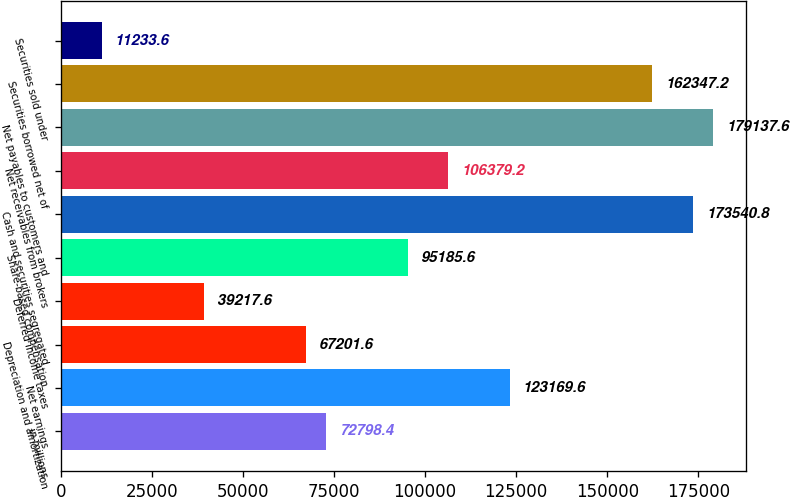Convert chart to OTSL. <chart><loc_0><loc_0><loc_500><loc_500><bar_chart><fcel>in millions<fcel>Net earnings<fcel>Depreciation and amortization<fcel>Deferred income taxes<fcel>Share-based compensation<fcel>Cash and securities segregated<fcel>Net receivables from brokers<fcel>Net payables to customers and<fcel>Securities borrowed net of<fcel>Securities sold under<nl><fcel>72798.4<fcel>123170<fcel>67201.6<fcel>39217.6<fcel>95185.6<fcel>173541<fcel>106379<fcel>179138<fcel>162347<fcel>11233.6<nl></chart> 